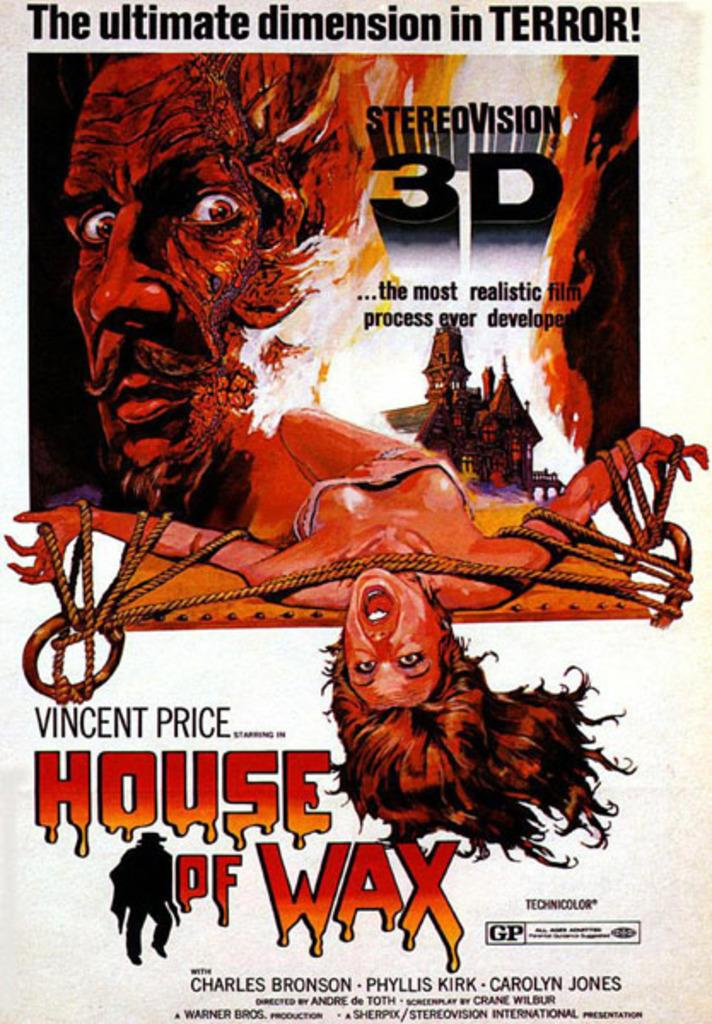<image>
Write a terse but informative summary of the picture. Vincent price starts in House of Wax on a poster promoting the film 